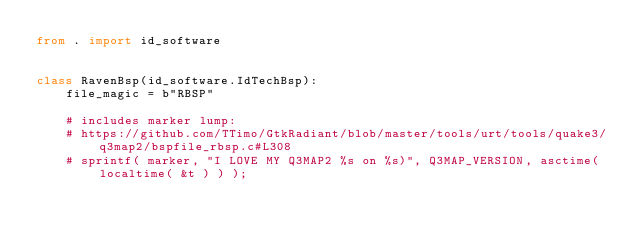<code> <loc_0><loc_0><loc_500><loc_500><_Python_>from . import id_software


class RavenBsp(id_software.IdTechBsp):
    file_magic = b"RBSP"

    # includes marker lump:
    # https://github.com/TTimo/GtkRadiant/blob/master/tools/urt/tools/quake3/q3map2/bspfile_rbsp.c#L308
    # sprintf( marker, "I LOVE MY Q3MAP2 %s on %s)", Q3MAP_VERSION, asctime( localtime( &t ) ) );
</code> 